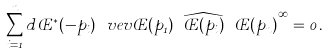<formula> <loc_0><loc_0><loc_500><loc_500>\sum _ { i = 1 } ^ { n } \L d { \phi ^ { * } ( - p _ { i } ) } \ v e v { \phi ( p _ { 1 } ) \cdots \widehat { \phi ( p _ { i } ) } \cdots \phi ( p _ { n } ) } ^ { \infty } = 0 \, .</formula> 